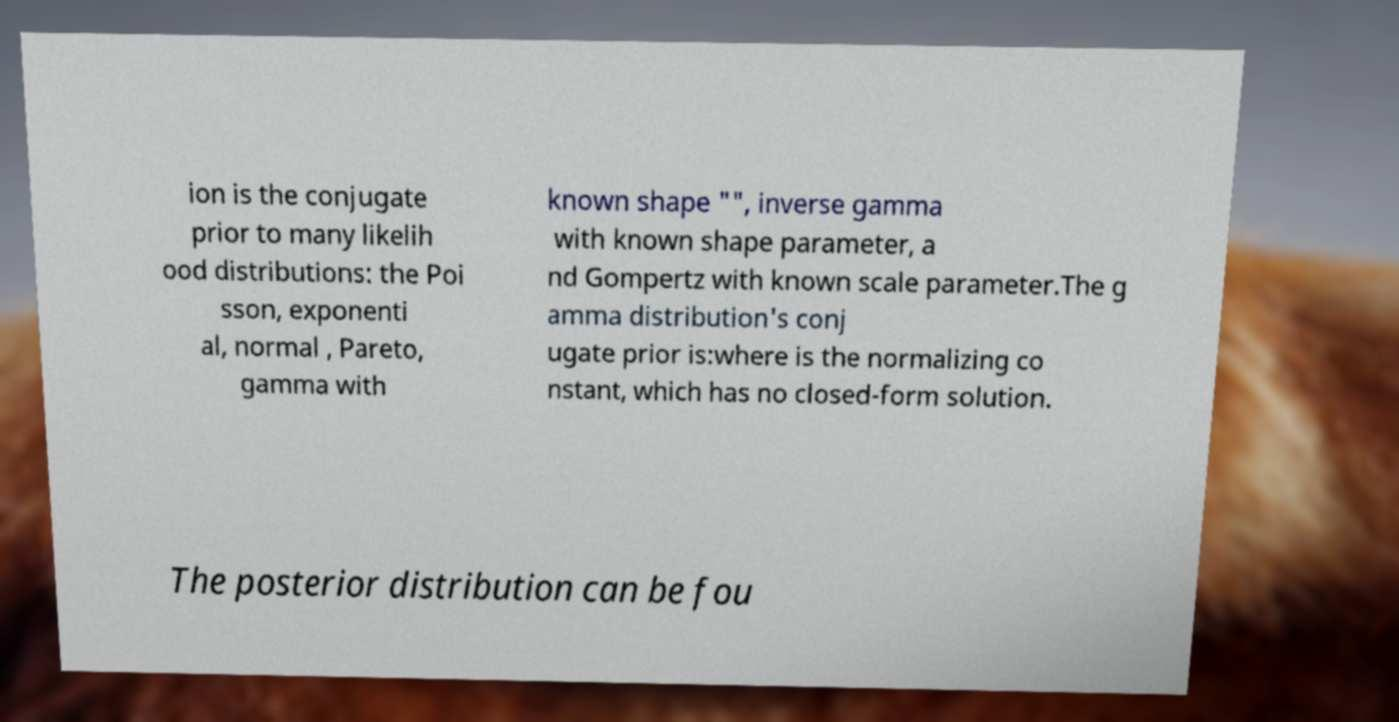Please read and relay the text visible in this image. What does it say? ion is the conjugate prior to many likelih ood distributions: the Poi sson, exponenti al, normal , Pareto, gamma with known shape "", inverse gamma with known shape parameter, a nd Gompertz with known scale parameter.The g amma distribution's conj ugate prior is:where is the normalizing co nstant, which has no closed-form solution. The posterior distribution can be fou 